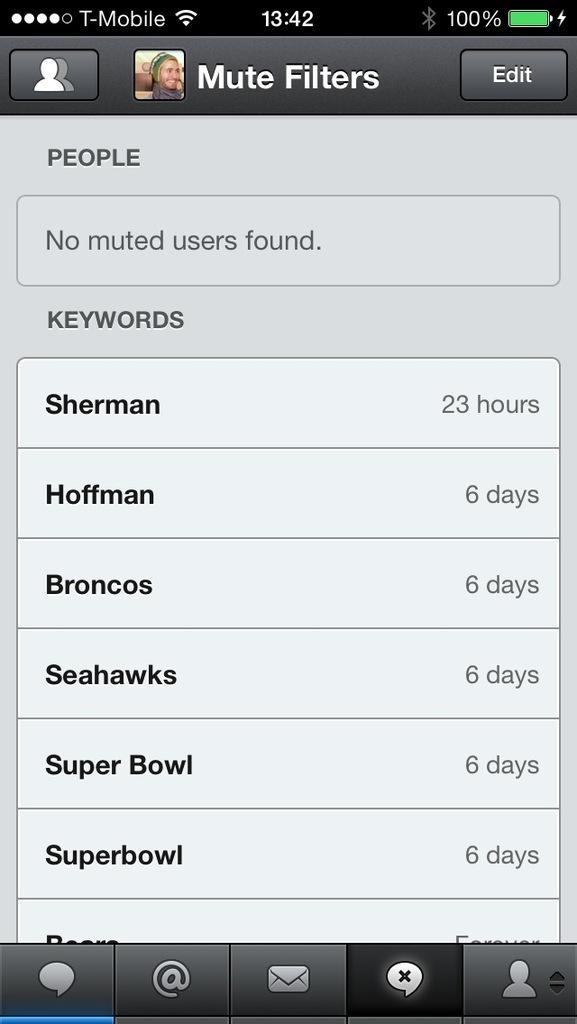<image>
Give a short and clear explanation of the subsequent image. The user's cell phone carrier for this device is T-mobile. 